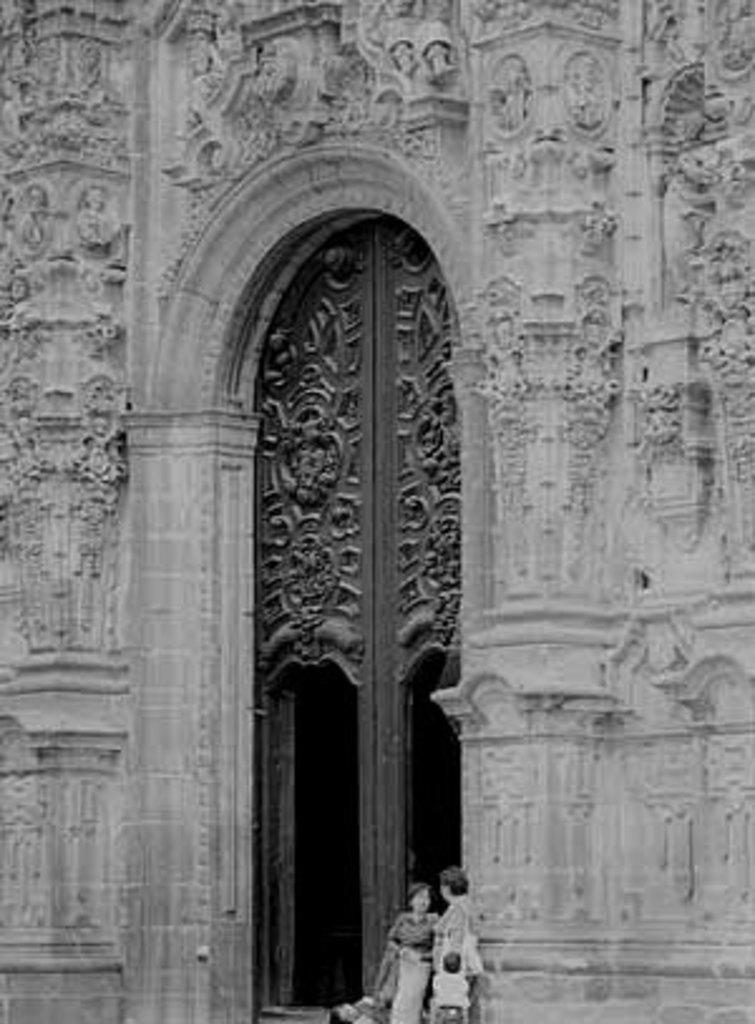What structure is depicted in the image? There is a building in the image. Are there any people present in the image? Yes, there are two persons standing at the bottom of the building. What feature can be seen in the middle of the building? There is a door in the middle of the building. What is the color scheme of the image? The image is black and white. What type of linen is being used by the committee in the image? There is no committee or linen present in the image; it only features a building and two persons. 